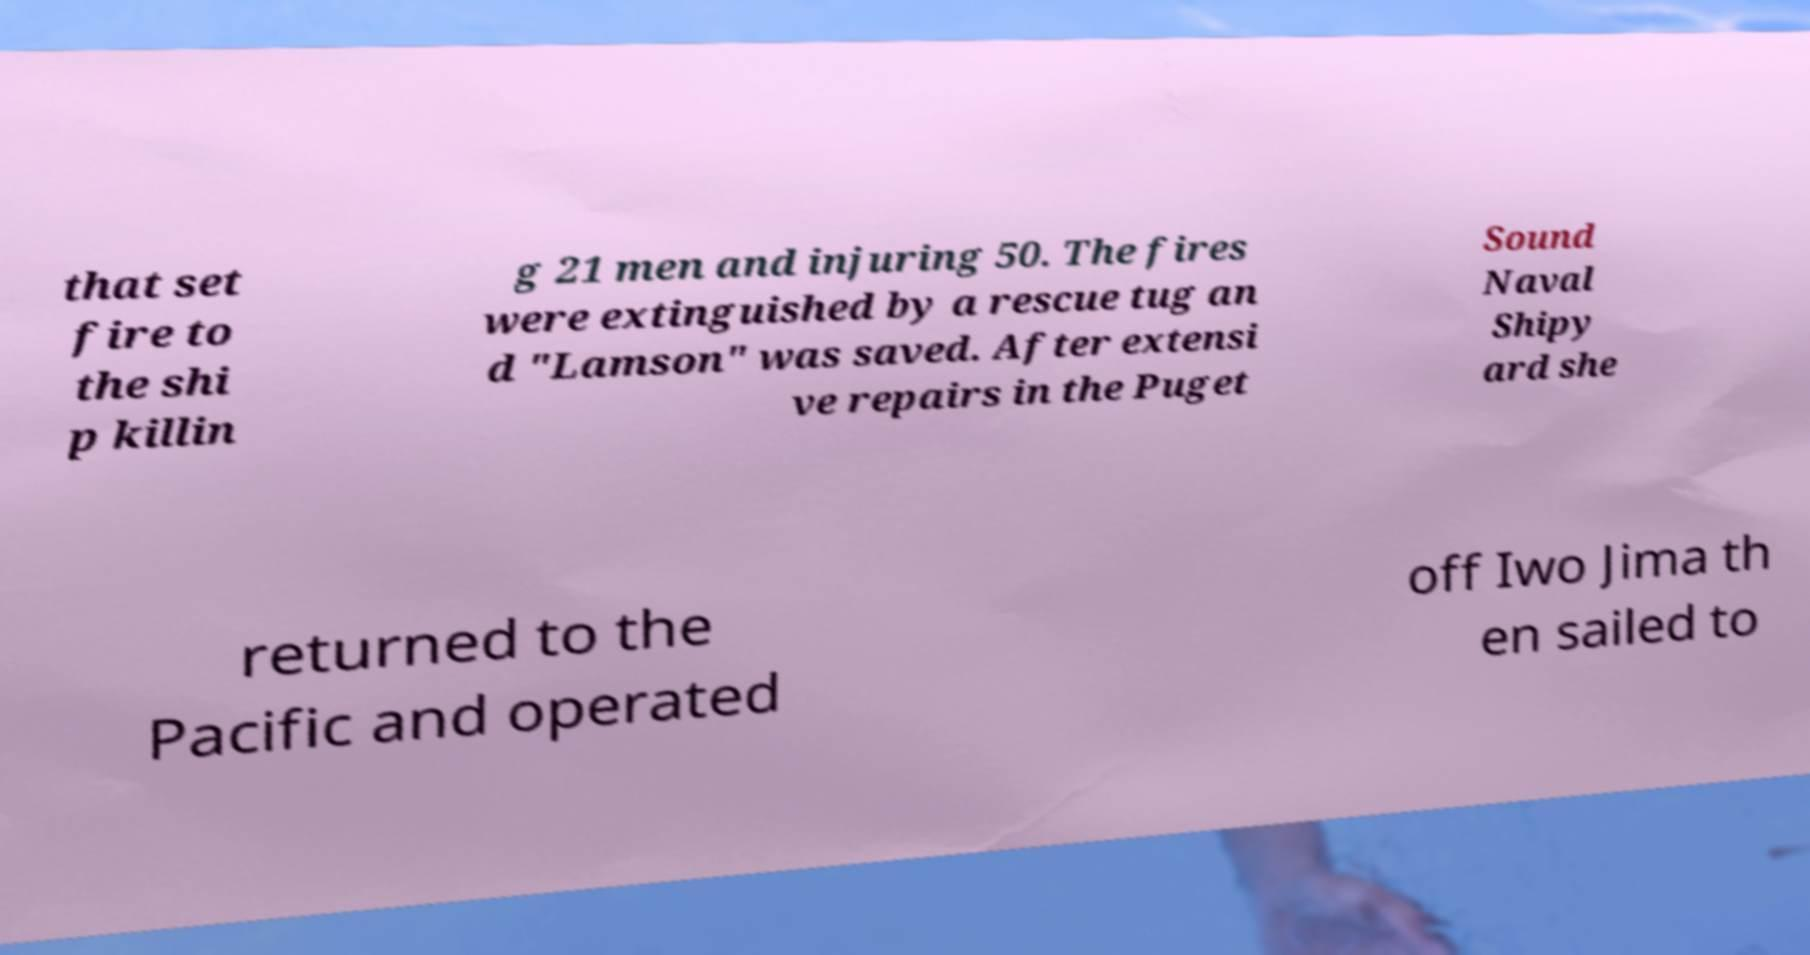There's text embedded in this image that I need extracted. Can you transcribe it verbatim? that set fire to the shi p killin g 21 men and injuring 50. The fires were extinguished by a rescue tug an d "Lamson" was saved. After extensi ve repairs in the Puget Sound Naval Shipy ard she returned to the Pacific and operated off Iwo Jima th en sailed to 